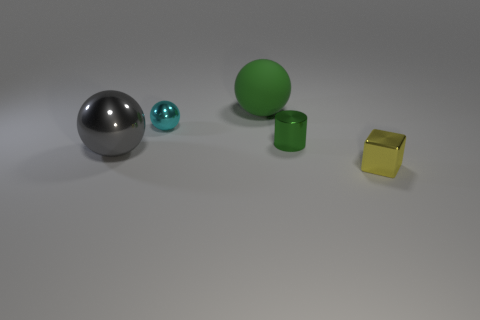Subtract all metallic balls. How many balls are left? 1 Add 1 large rubber things. How many objects exist? 6 Subtract all cylinders. How many objects are left? 4 Subtract 1 green balls. How many objects are left? 4 Subtract all large cyan blocks. Subtract all small cyan metal spheres. How many objects are left? 4 Add 5 tiny metallic objects. How many tiny metallic objects are left? 8 Add 3 tiny gray rubber blocks. How many tiny gray rubber blocks exist? 3 